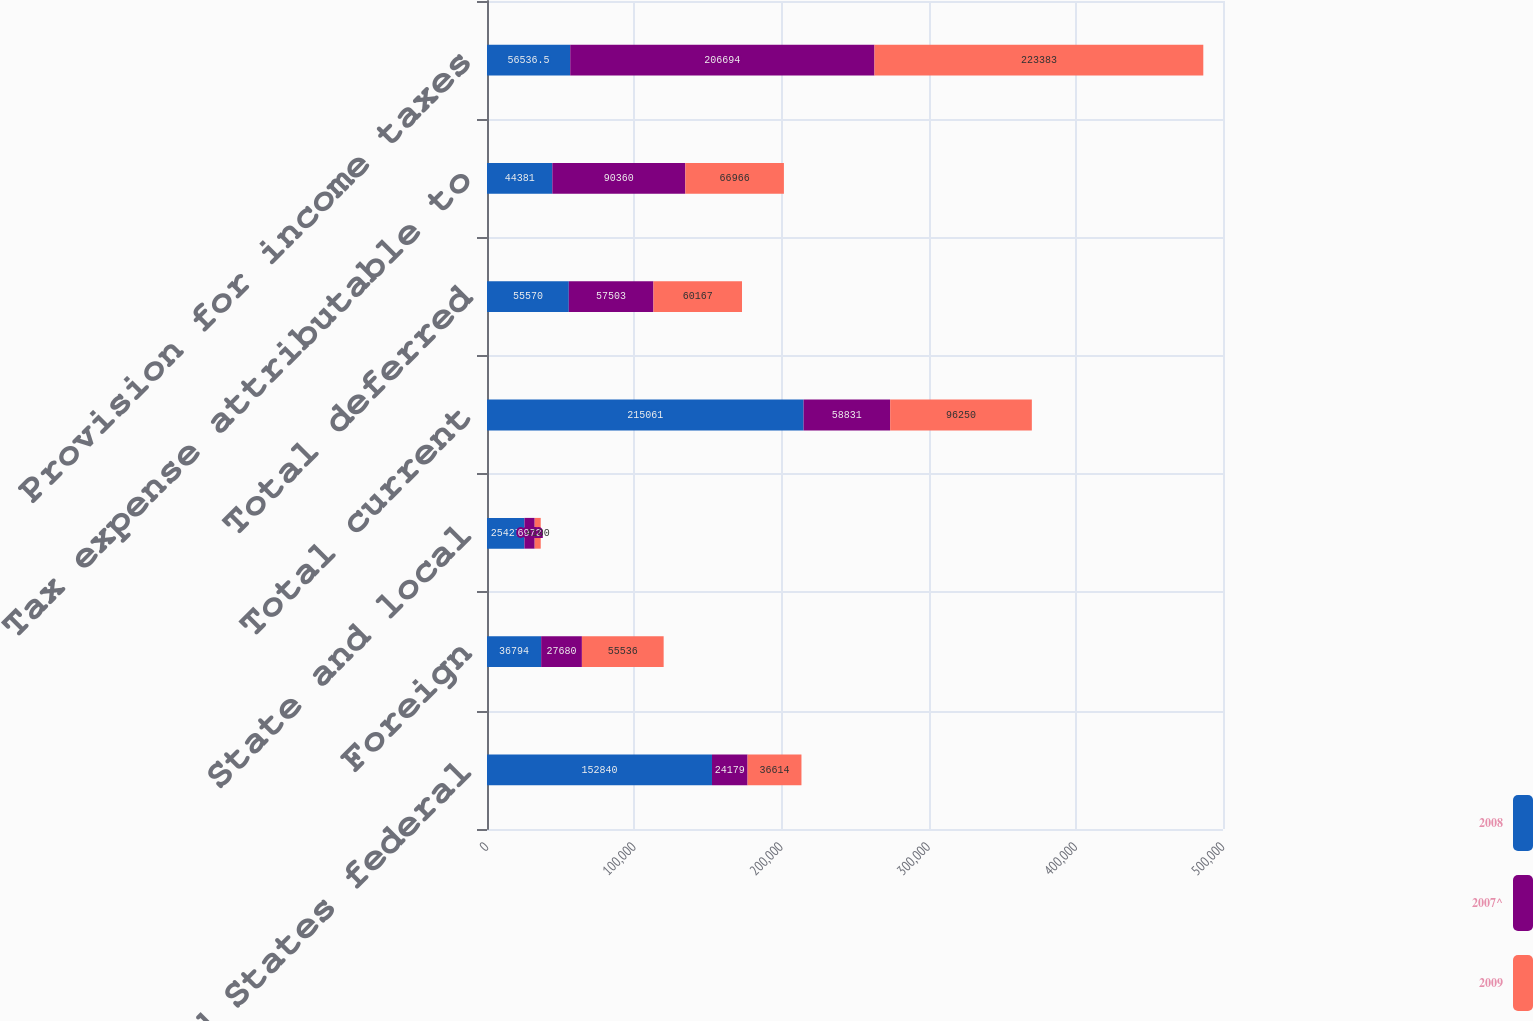<chart> <loc_0><loc_0><loc_500><loc_500><stacked_bar_chart><ecel><fcel>United States federal<fcel>Foreign<fcel>State and local<fcel>Total current<fcel>Total deferred<fcel>Tax expense attributable to<fcel>Provision for income taxes<nl><fcel>2008<fcel>152840<fcel>36794<fcel>25427<fcel>215061<fcel>55570<fcel>44381<fcel>56536.5<nl><fcel>2007^<fcel>24179<fcel>27680<fcel>6972<fcel>58831<fcel>57503<fcel>90360<fcel>206694<nl><fcel>2009<fcel>36614<fcel>55536<fcel>4100<fcel>96250<fcel>60167<fcel>66966<fcel>223383<nl></chart> 